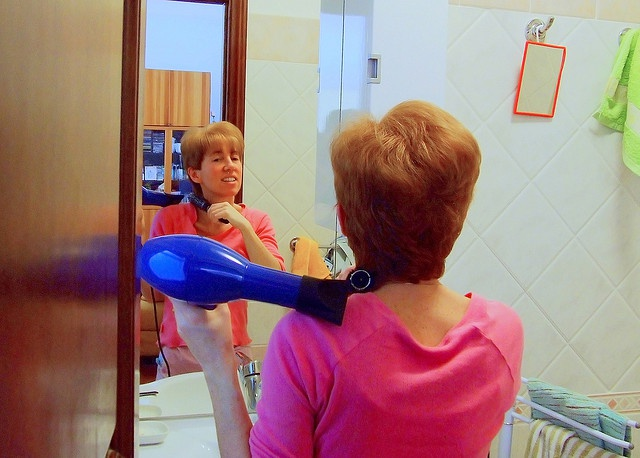Describe the objects in this image and their specific colors. I can see people in tan, brown, and maroon tones, hair drier in gray, darkblue, navy, black, and blue tones, and sink in gray, lightgray, and darkgray tones in this image. 